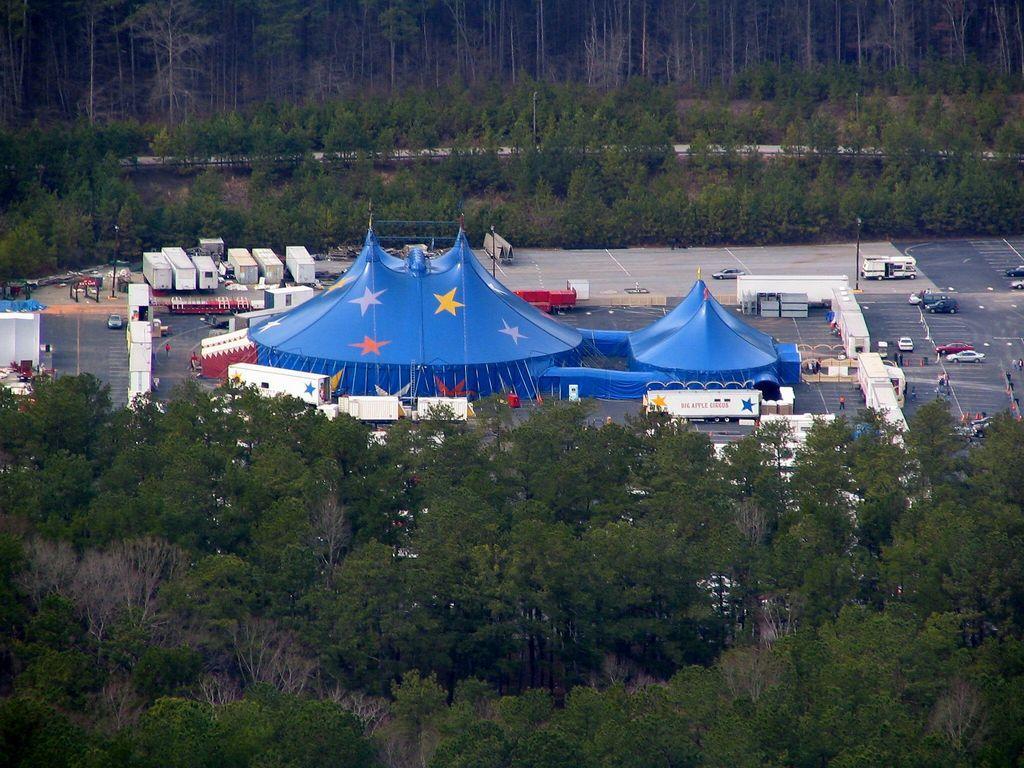Please provide a concise description of this image. In this image, these look like tents, which are blue in color. I think these are the iron containers. I can see few vehicles on the road. These are the trees with branches and leaves. 